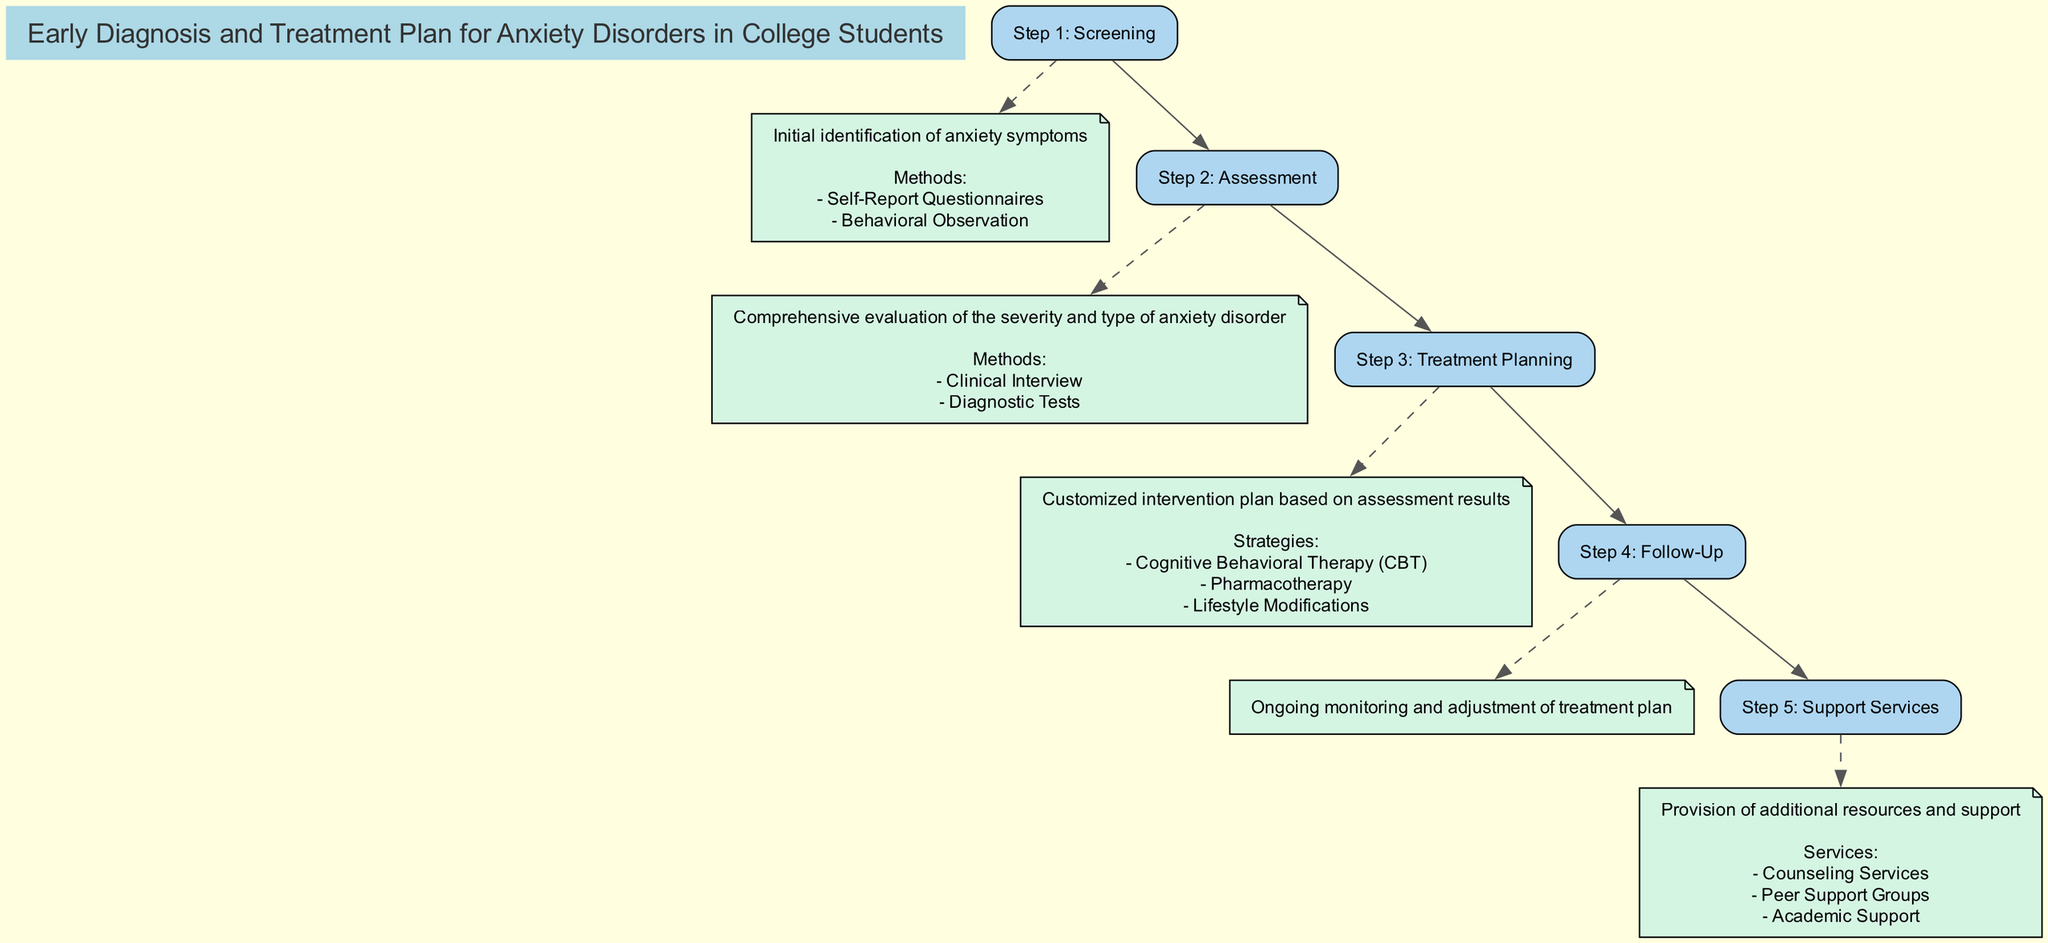What is the goal of the clinical pathway? The goal is stated at the beginning of the diagram, which aims to facilitate early identification and management of anxiety disorders among college students.
Answer: Facilitate early identification and management of anxiety disorders among college students How many steps are in the clinical pathway? The diagram shows a total of five steps listed sequentially through the pathway.
Answer: 5 What is the first step in the clinical pathway? By examining the diagram, the first step is identified as "Screening," which is the initial identification of anxiety symptoms.
Answer: Screening What strategies are included in the Treatment Planning step? The Treatment Planning step includes various strategies. By reviewing the details for this step, three strategies can be identified: Cognitive Behavioral Therapy, Pharmacotherapy, and Lifestyle Modifications.
Answer: Cognitive Behavioral Therapy, Pharmacotherapy, Lifestyle Modifications Which service is provided by the University Counseling Center? Referring to the Support Services section of the diagram, one of the services explicitly mentioned that is provided is Counseling Services.
Answer: Counseling Services What methods are used in the Screening step? The Screening step outlines specific methods used for identifying anxiety symptoms and includes two methods, which are Self-Report Questionnaires and Behavioral Observation.
Answer: Self-Report Questionnaires, Behavioral Observation Which strategy involves cognitive restructuring? If we look at the Treatment Planning step, Cognitive Behavioral Therapy includes components such as cognitive restructuring as a key strategy within this intervention plan.
Answer: Cognitive Behavioral Therapy How often are follow-ups scheduled? The Follow-Up step mentions the frequency of follow-up as "Monthly Check-Ins" and "Quarterly Evaluation," which indicates specific timeframes for ongoing monitoring.
Answer: Monthly Check-Ins, Quarterly Evaluation What tools are used in the Assessment step? Upon examining the Assessment step, the tools used include Structured Clinical Interview for DSM-5 and Mini International Neuropsychiatric Interview as part of the comprehensive evaluation process.
Answer: Structured Clinical Interview for DSM-5, Mini International Neuropsychiatric Interview 